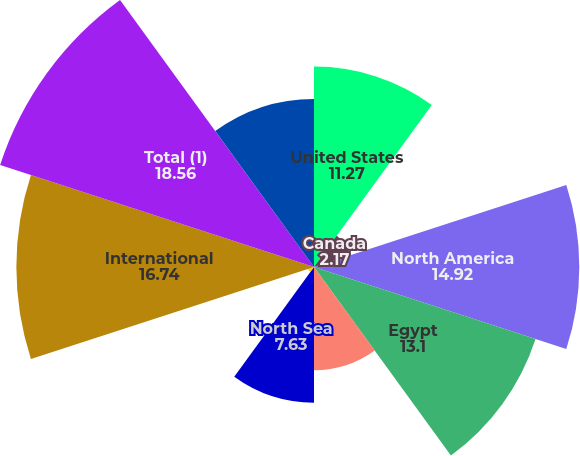Convert chart. <chart><loc_0><loc_0><loc_500><loc_500><pie_chart><fcel>United States<fcel>Canada<fcel>North America<fcel>Egypt<fcel>Australia<fcel>North Sea<fcel>Argentina<fcel>International<fcel>Total (1)<fcel>Total (2)<nl><fcel>11.27%<fcel>2.17%<fcel>14.92%<fcel>13.1%<fcel>5.81%<fcel>7.63%<fcel>0.35%<fcel>16.74%<fcel>18.56%<fcel>9.45%<nl></chart> 